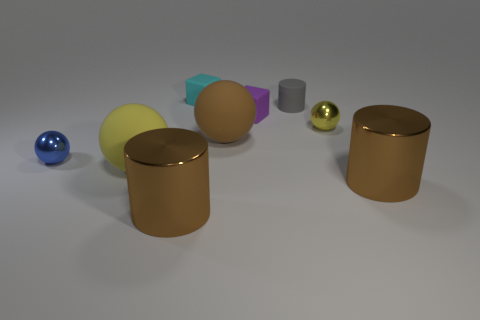What could be the possible use of these objects in real life? While these objects are likely digital renderings and not real, they do resemble items that could exist in real life. The spheres might serve as decorative ornaments or parts of a children's playset. The cylinders could be containers or parts of machinery, while the cuboid could be used as a paperweight or display object. The array appears to be a staged collection to demonstrate shapes, reflections, and textures, which could be useful in an educational or artistic context. 